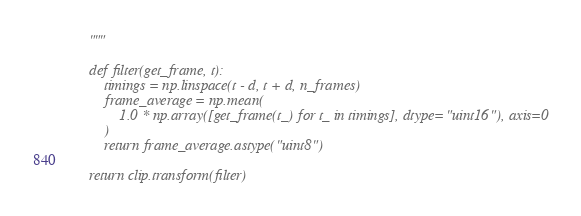Convert code to text. <code><loc_0><loc_0><loc_500><loc_500><_Python_>    """

    def filter(get_frame, t):
        timings = np.linspace(t - d, t + d, n_frames)
        frame_average = np.mean(
            1.0 * np.array([get_frame(t_) for t_ in timings], dtype="uint16"), axis=0
        )
        return frame_average.astype("uint8")

    return clip.transform(filter)
</code> 